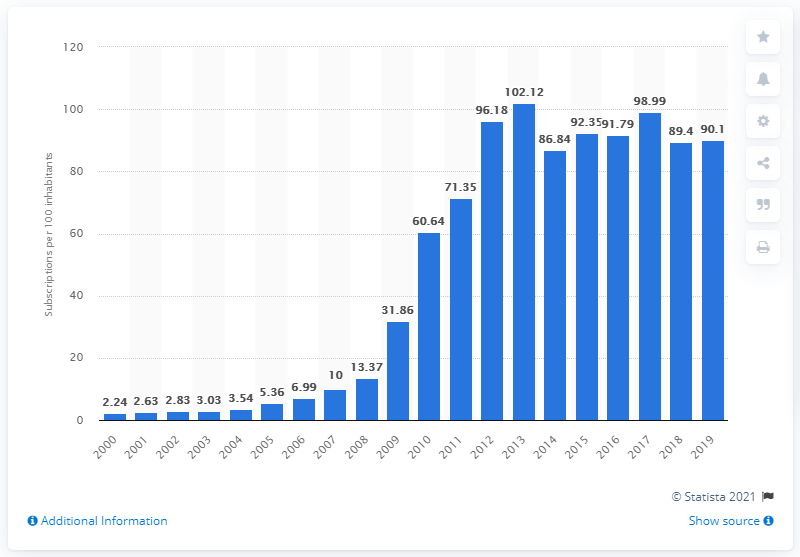Highlight a few significant elements in this photo. During the period between 2000 and 2019, an average of 90.1 mobile subscriptions were registered for every 100 people in Zimbabwe. 